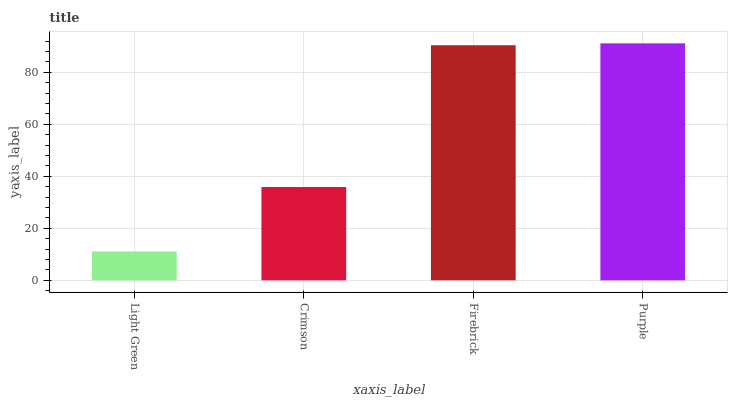Is Light Green the minimum?
Answer yes or no. Yes. Is Purple the maximum?
Answer yes or no. Yes. Is Crimson the minimum?
Answer yes or no. No. Is Crimson the maximum?
Answer yes or no. No. Is Crimson greater than Light Green?
Answer yes or no. Yes. Is Light Green less than Crimson?
Answer yes or no. Yes. Is Light Green greater than Crimson?
Answer yes or no. No. Is Crimson less than Light Green?
Answer yes or no. No. Is Firebrick the high median?
Answer yes or no. Yes. Is Crimson the low median?
Answer yes or no. Yes. Is Purple the high median?
Answer yes or no. No. Is Purple the low median?
Answer yes or no. No. 